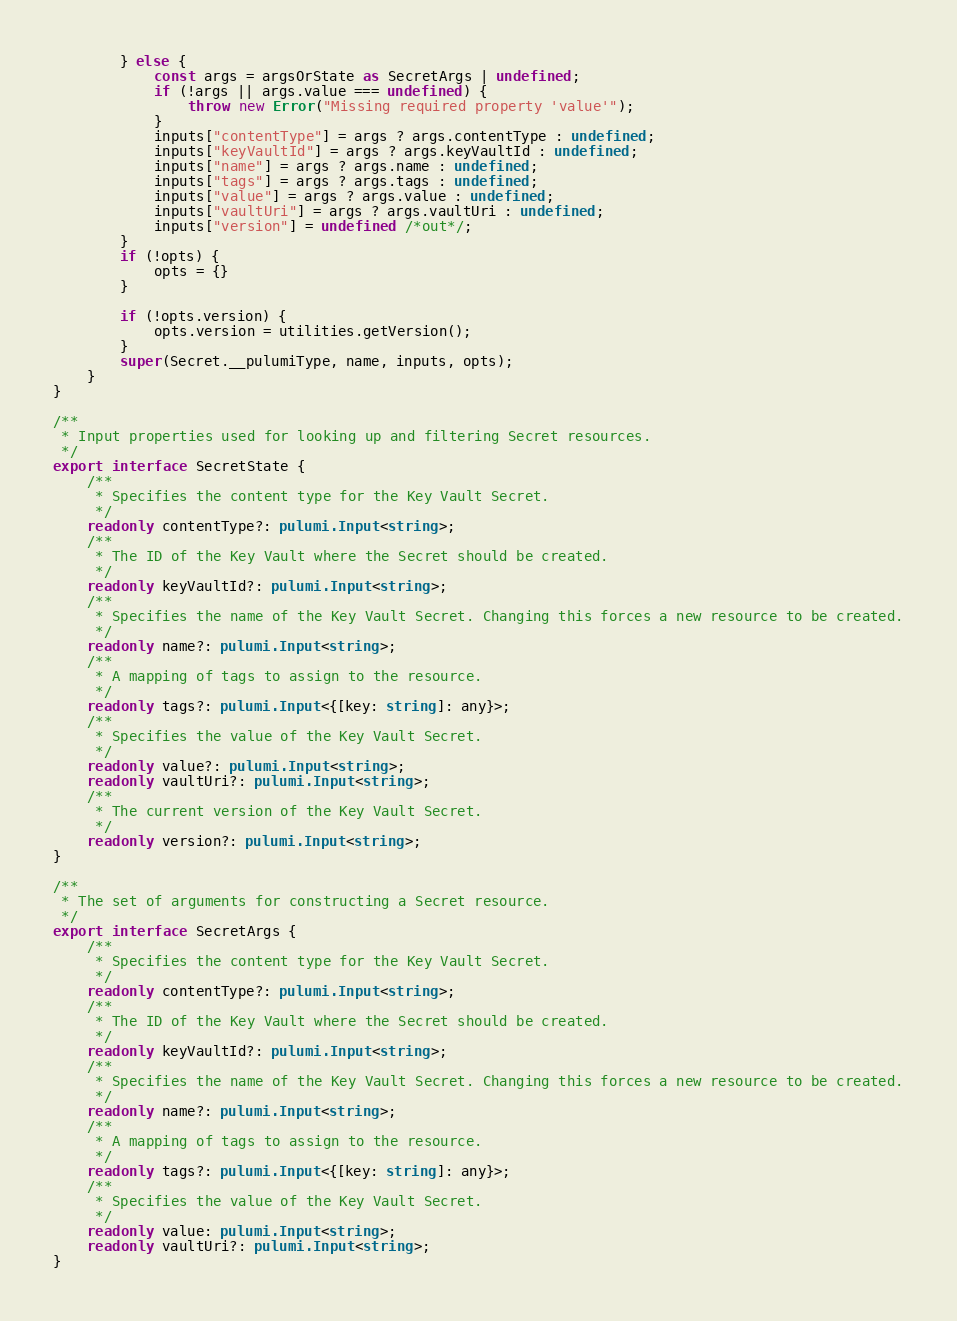Convert code to text. <code><loc_0><loc_0><loc_500><loc_500><_TypeScript_>        } else {
            const args = argsOrState as SecretArgs | undefined;
            if (!args || args.value === undefined) {
                throw new Error("Missing required property 'value'");
            }
            inputs["contentType"] = args ? args.contentType : undefined;
            inputs["keyVaultId"] = args ? args.keyVaultId : undefined;
            inputs["name"] = args ? args.name : undefined;
            inputs["tags"] = args ? args.tags : undefined;
            inputs["value"] = args ? args.value : undefined;
            inputs["vaultUri"] = args ? args.vaultUri : undefined;
            inputs["version"] = undefined /*out*/;
        }
        if (!opts) {
            opts = {}
        }

        if (!opts.version) {
            opts.version = utilities.getVersion();
        }
        super(Secret.__pulumiType, name, inputs, opts);
    }
}

/**
 * Input properties used for looking up and filtering Secret resources.
 */
export interface SecretState {
    /**
     * Specifies the content type for the Key Vault Secret.
     */
    readonly contentType?: pulumi.Input<string>;
    /**
     * The ID of the Key Vault where the Secret should be created.
     */
    readonly keyVaultId?: pulumi.Input<string>;
    /**
     * Specifies the name of the Key Vault Secret. Changing this forces a new resource to be created.
     */
    readonly name?: pulumi.Input<string>;
    /**
     * A mapping of tags to assign to the resource.
     */
    readonly tags?: pulumi.Input<{[key: string]: any}>;
    /**
     * Specifies the value of the Key Vault Secret.
     */
    readonly value?: pulumi.Input<string>;
    readonly vaultUri?: pulumi.Input<string>;
    /**
     * The current version of the Key Vault Secret.
     */
    readonly version?: pulumi.Input<string>;
}

/**
 * The set of arguments for constructing a Secret resource.
 */
export interface SecretArgs {
    /**
     * Specifies the content type for the Key Vault Secret.
     */
    readonly contentType?: pulumi.Input<string>;
    /**
     * The ID of the Key Vault where the Secret should be created.
     */
    readonly keyVaultId?: pulumi.Input<string>;
    /**
     * Specifies the name of the Key Vault Secret. Changing this forces a new resource to be created.
     */
    readonly name?: pulumi.Input<string>;
    /**
     * A mapping of tags to assign to the resource.
     */
    readonly tags?: pulumi.Input<{[key: string]: any}>;
    /**
     * Specifies the value of the Key Vault Secret.
     */
    readonly value: pulumi.Input<string>;
    readonly vaultUri?: pulumi.Input<string>;
}
</code> 